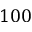Convert formula to latex. <formula><loc_0><loc_0><loc_500><loc_500>1 0 0</formula> 